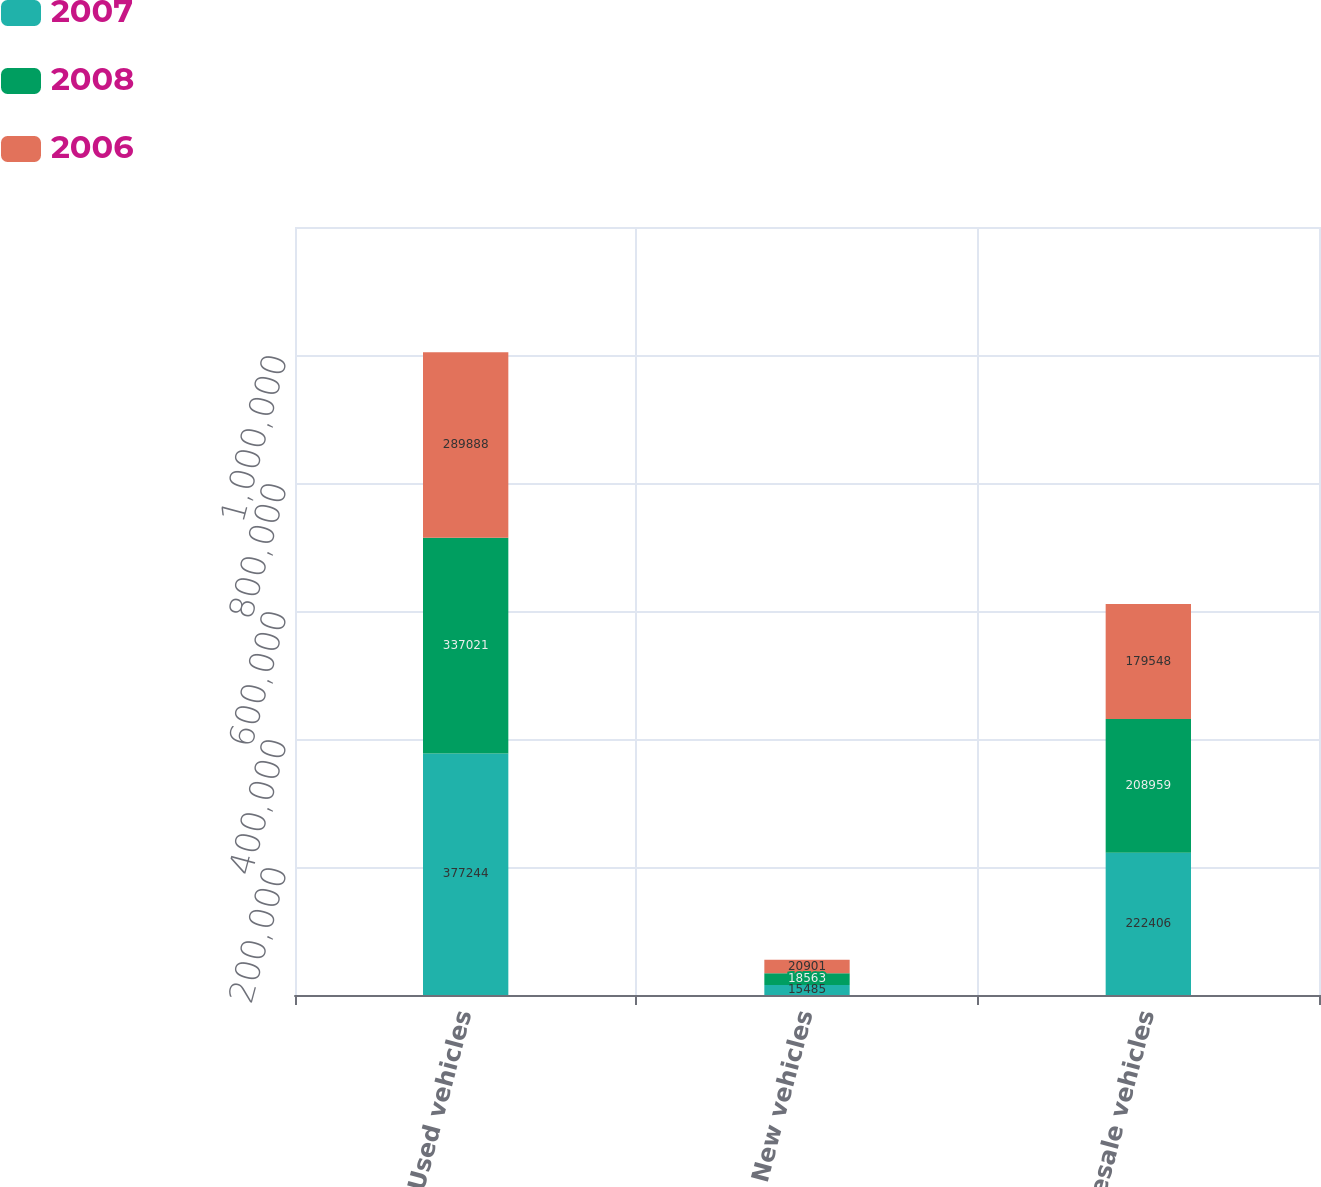<chart> <loc_0><loc_0><loc_500><loc_500><stacked_bar_chart><ecel><fcel>Used vehicles<fcel>New vehicles<fcel>Wholesale vehicles<nl><fcel>2007<fcel>377244<fcel>15485<fcel>222406<nl><fcel>2008<fcel>337021<fcel>18563<fcel>208959<nl><fcel>2006<fcel>289888<fcel>20901<fcel>179548<nl></chart> 